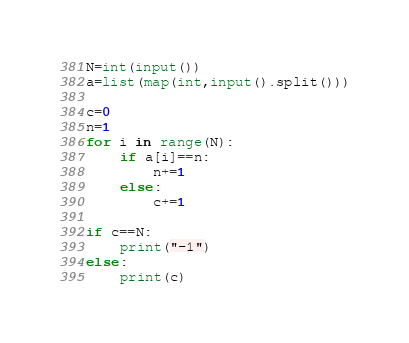Convert code to text. <code><loc_0><loc_0><loc_500><loc_500><_Python_>N=int(input())
a=list(map(int,input().split()))

c=0 
n=1
for i in range(N):
    if a[i]==n:
        n+=1
    else:
        c+=1

if c==N:
    print("-1")
else:
    print(c)
</code> 